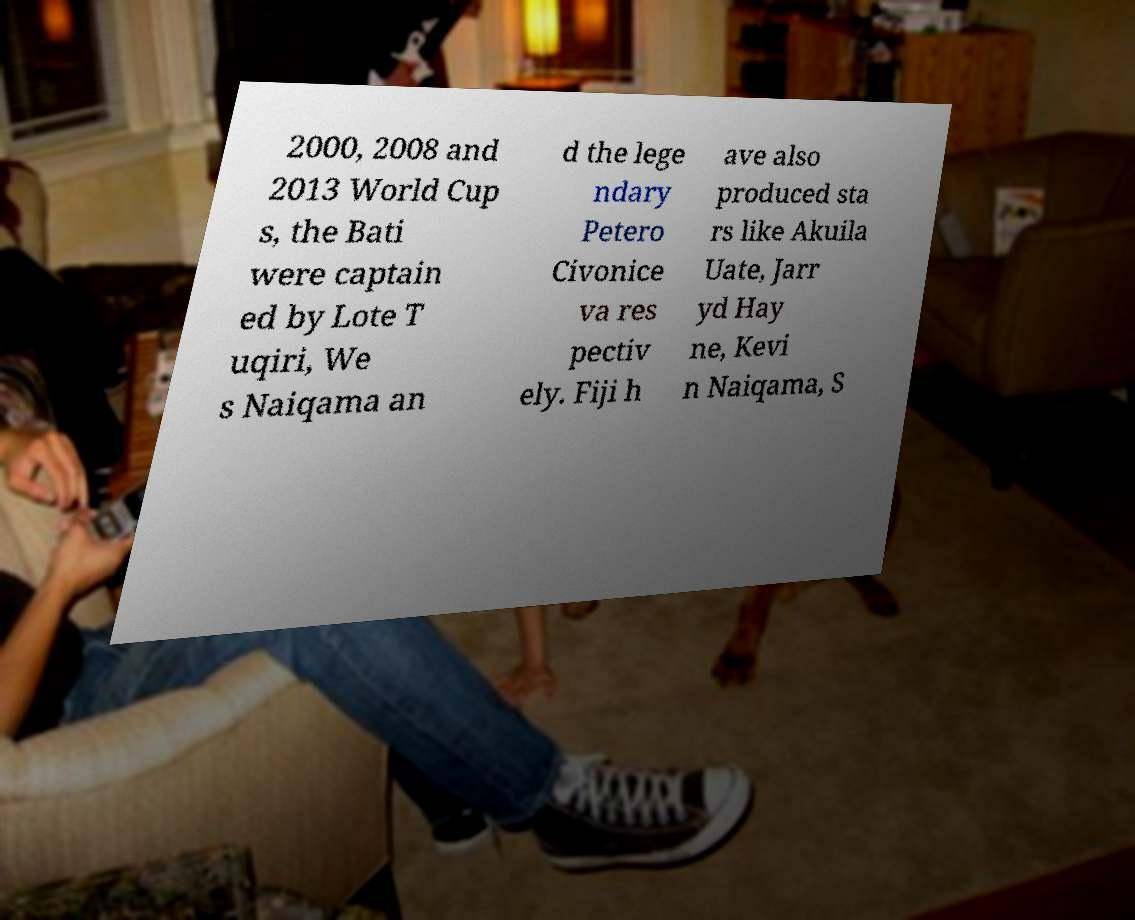There's text embedded in this image that I need extracted. Can you transcribe it verbatim? 2000, 2008 and 2013 World Cup s, the Bati were captain ed by Lote T uqiri, We s Naiqama an d the lege ndary Petero Civonice va res pectiv ely. Fiji h ave also produced sta rs like Akuila Uate, Jarr yd Hay ne, Kevi n Naiqama, S 